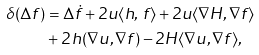Convert formula to latex. <formula><loc_0><loc_0><loc_500><loc_500>\delta ( \Delta f ) & = \Delta \dot { f } + 2 u \langle h , \, f \rangle + 2 u \langle \nabla H , \nabla f \rangle \\ & + 2 \, h ( \nabla { u } , \nabla { f } ) - 2 H \langle \nabla u , \nabla f \rangle ,</formula> 